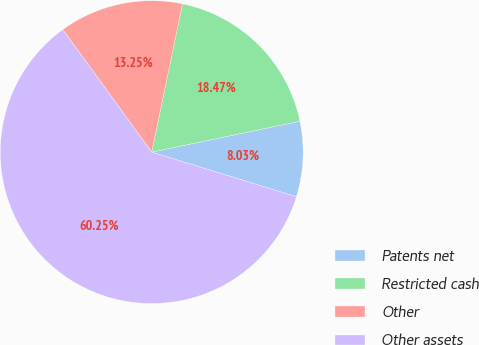Convert chart to OTSL. <chart><loc_0><loc_0><loc_500><loc_500><pie_chart><fcel>Patents net<fcel>Restricted cash<fcel>Other<fcel>Other assets<nl><fcel>8.03%<fcel>18.47%<fcel>13.25%<fcel>60.25%<nl></chart> 